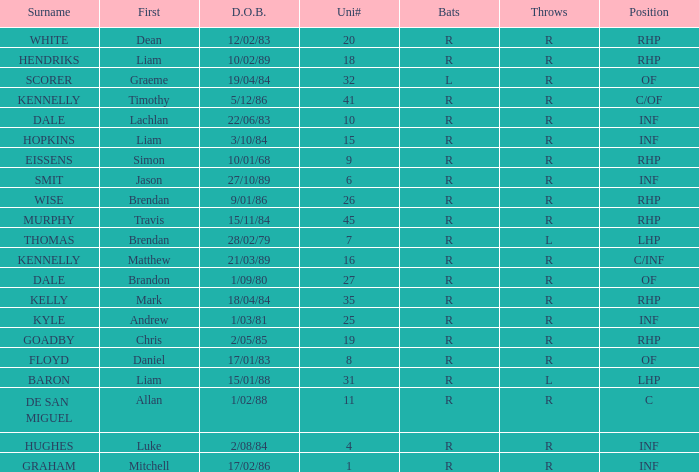Which batter has the last name Graham? R. 